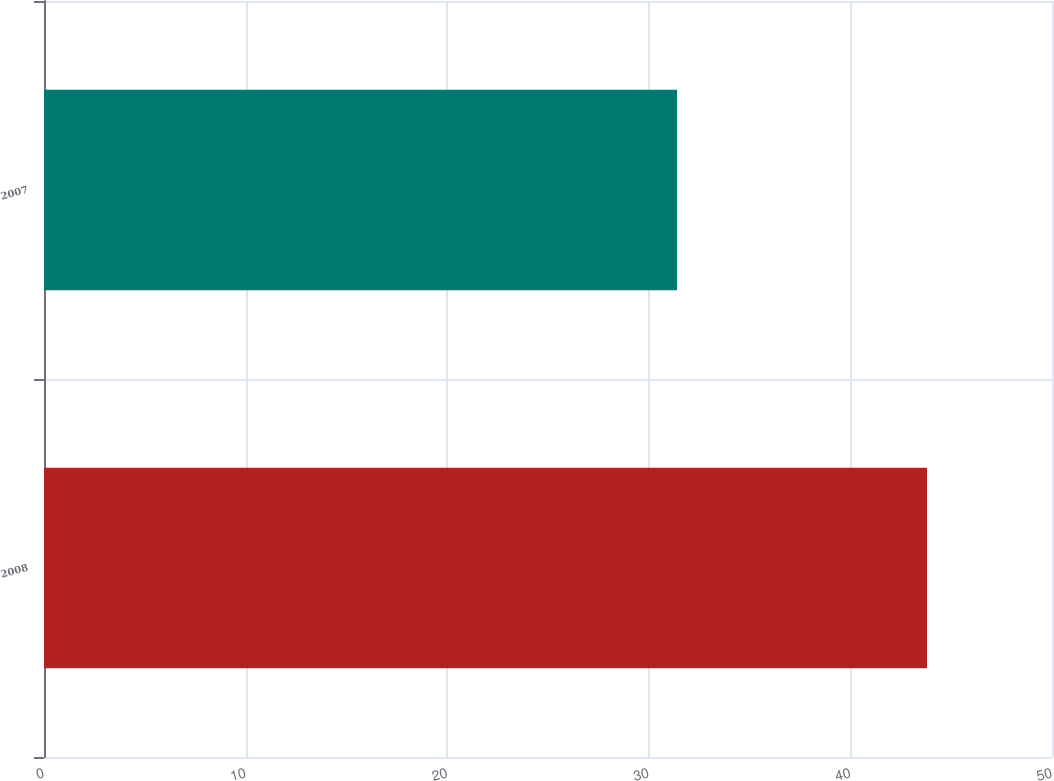Convert chart. <chart><loc_0><loc_0><loc_500><loc_500><bar_chart><fcel>2008<fcel>2007<nl><fcel>43.8<fcel>31.4<nl></chart> 